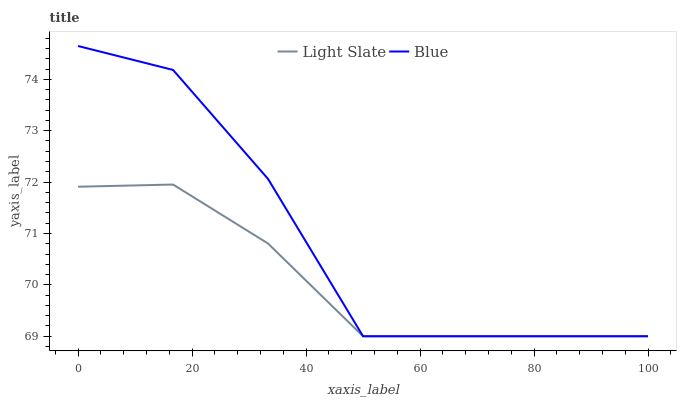Does Light Slate have the minimum area under the curve?
Answer yes or no. Yes. Does Blue have the maximum area under the curve?
Answer yes or no. Yes. Does Blue have the minimum area under the curve?
Answer yes or no. No. Is Light Slate the smoothest?
Answer yes or no. Yes. Is Blue the roughest?
Answer yes or no. Yes. Is Blue the smoothest?
Answer yes or no. No. Does Light Slate have the lowest value?
Answer yes or no. Yes. Does Blue have the highest value?
Answer yes or no. Yes. Does Light Slate intersect Blue?
Answer yes or no. Yes. Is Light Slate less than Blue?
Answer yes or no. No. Is Light Slate greater than Blue?
Answer yes or no. No. 